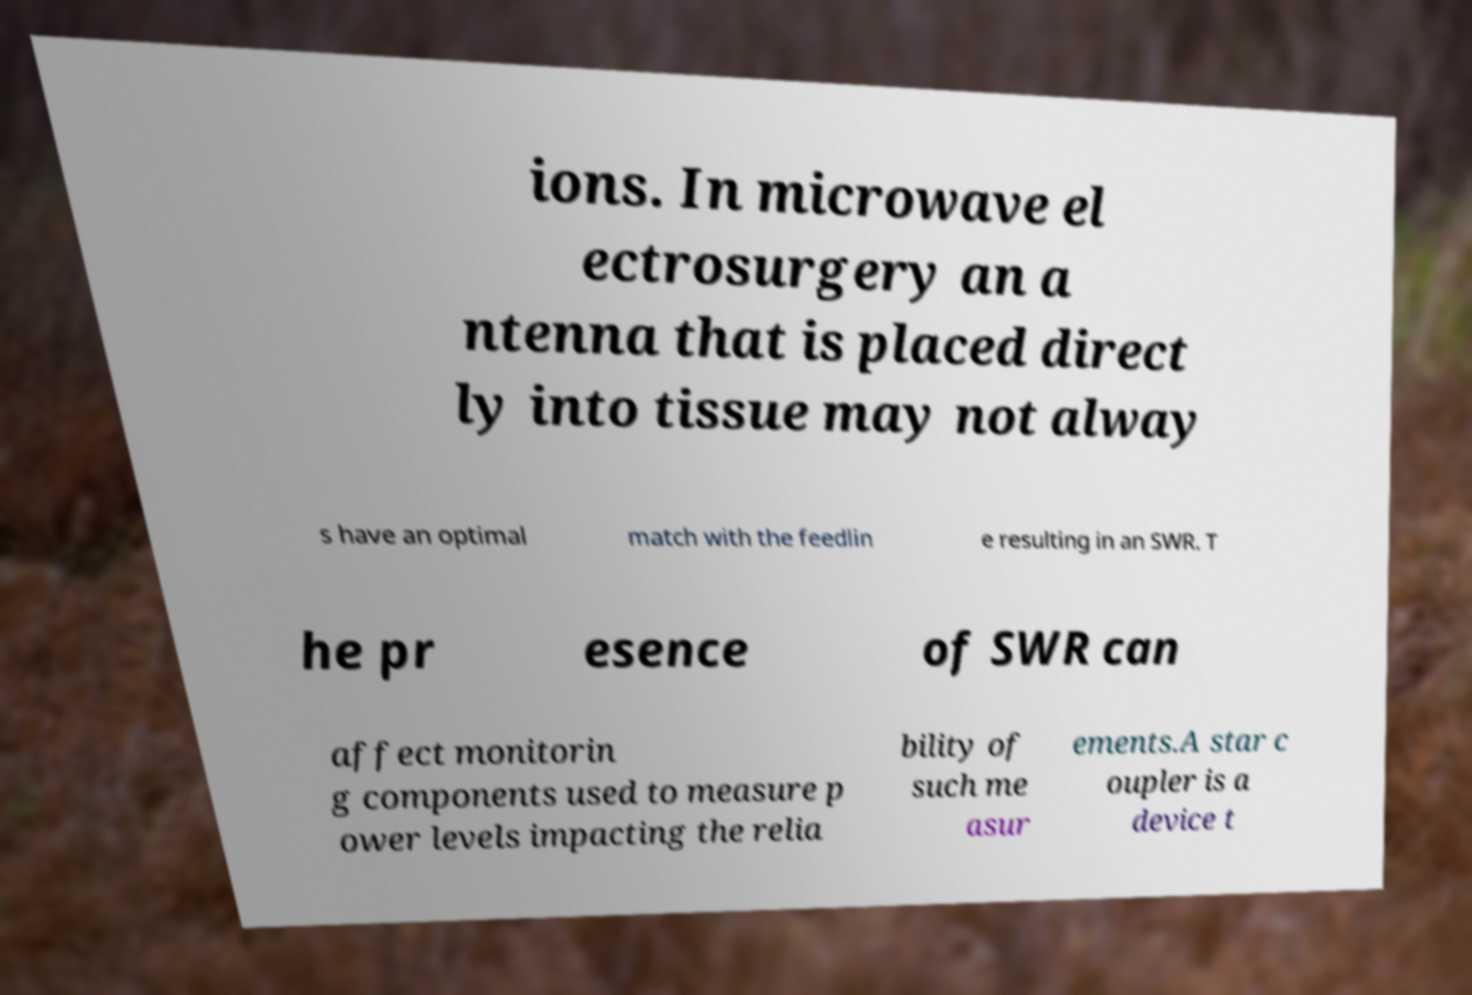Can you accurately transcribe the text from the provided image for me? ions. In microwave el ectrosurgery an a ntenna that is placed direct ly into tissue may not alway s have an optimal match with the feedlin e resulting in an SWR. T he pr esence of SWR can affect monitorin g components used to measure p ower levels impacting the relia bility of such me asur ements.A star c oupler is a device t 